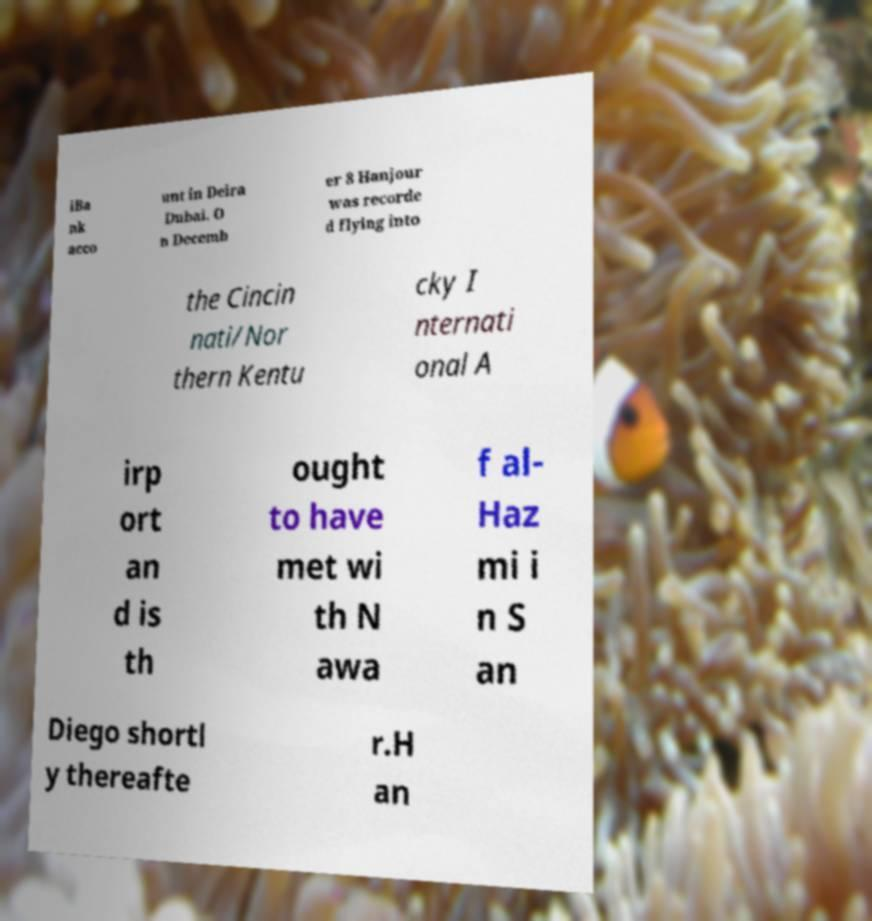There's text embedded in this image that I need extracted. Can you transcribe it verbatim? iBa nk acco unt in Deira Dubai. O n Decemb er 8 Hanjour was recorde d flying into the Cincin nati/Nor thern Kentu cky I nternati onal A irp ort an d is th ought to have met wi th N awa f al- Haz mi i n S an Diego shortl y thereafte r.H an 